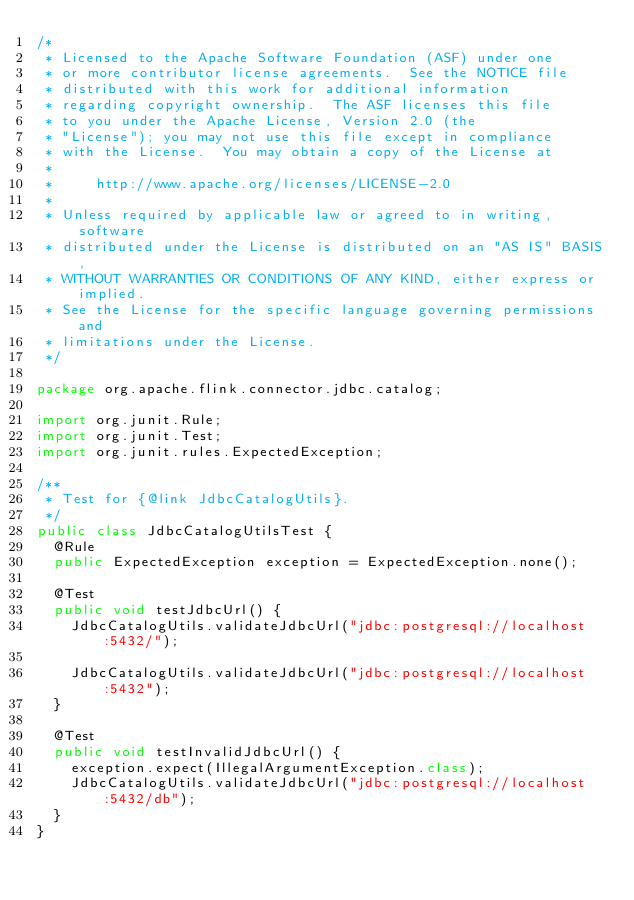Convert code to text. <code><loc_0><loc_0><loc_500><loc_500><_Java_>/*
 * Licensed to the Apache Software Foundation (ASF) under one
 * or more contributor license agreements.  See the NOTICE file
 * distributed with this work for additional information
 * regarding copyright ownership.  The ASF licenses this file
 * to you under the Apache License, Version 2.0 (the
 * "License"); you may not use this file except in compliance
 * with the License.  You may obtain a copy of the License at
 *
 *     http://www.apache.org/licenses/LICENSE-2.0
 *
 * Unless required by applicable law or agreed to in writing, software
 * distributed under the License is distributed on an "AS IS" BASIS,
 * WITHOUT WARRANTIES OR CONDITIONS OF ANY KIND, either express or implied.
 * See the License for the specific language governing permissions and
 * limitations under the License.
 */

package org.apache.flink.connector.jdbc.catalog;

import org.junit.Rule;
import org.junit.Test;
import org.junit.rules.ExpectedException;

/**
 * Test for {@link JdbcCatalogUtils}.
 */
public class JdbcCatalogUtilsTest {
	@Rule
	public ExpectedException exception = ExpectedException.none();

	@Test
	public void testJdbcUrl() {
		JdbcCatalogUtils.validateJdbcUrl("jdbc:postgresql://localhost:5432/");

		JdbcCatalogUtils.validateJdbcUrl("jdbc:postgresql://localhost:5432");
	}

	@Test
	public void testInvalidJdbcUrl() {
		exception.expect(IllegalArgumentException.class);
		JdbcCatalogUtils.validateJdbcUrl("jdbc:postgresql://localhost:5432/db");
	}
}
</code> 